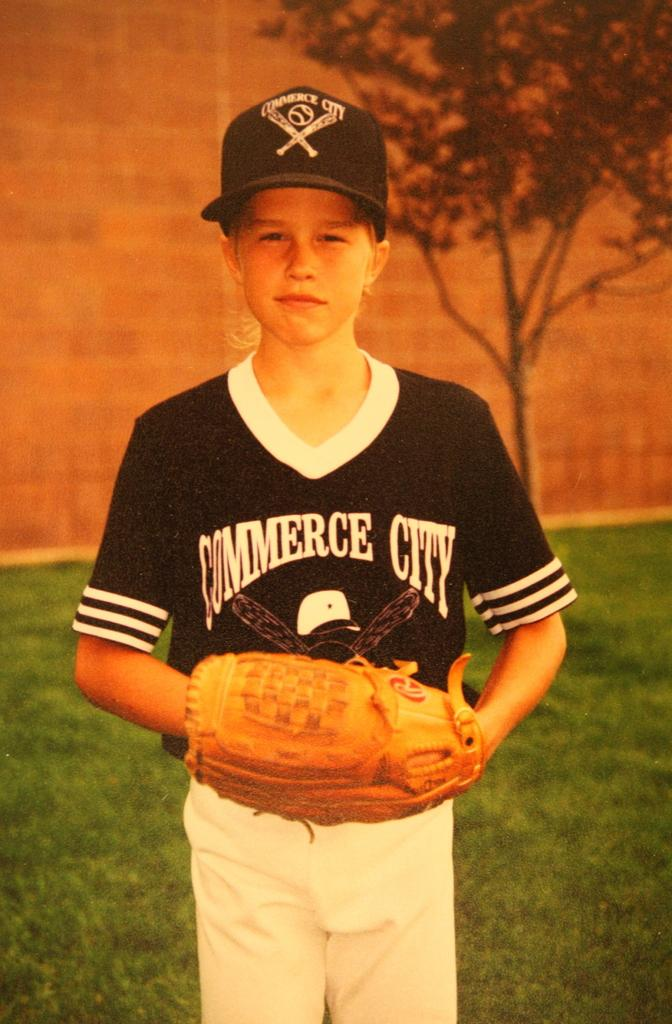What is in the bowl that is visible in the image? The facts do not specify what is in the bowl. What can be seen on the person's hands in the image? The person in the image is wearing gloves. What color is the shirt the person is wearing? The person is wearing a black shirt. What color are the pants the person is wearing? The person is wearing white pants. What type of headwear is the person wearing? The person is wearing a cap. What type of vegetation is visible in the background of the image? There is a tree visible in the background of the image. What type of spoon is the person using to make a discovery in the image? There is no spoon or discovery present in the image. How much salt is visible on the person's clothing in the image? There is no salt visible on the person's clothing in the image. 